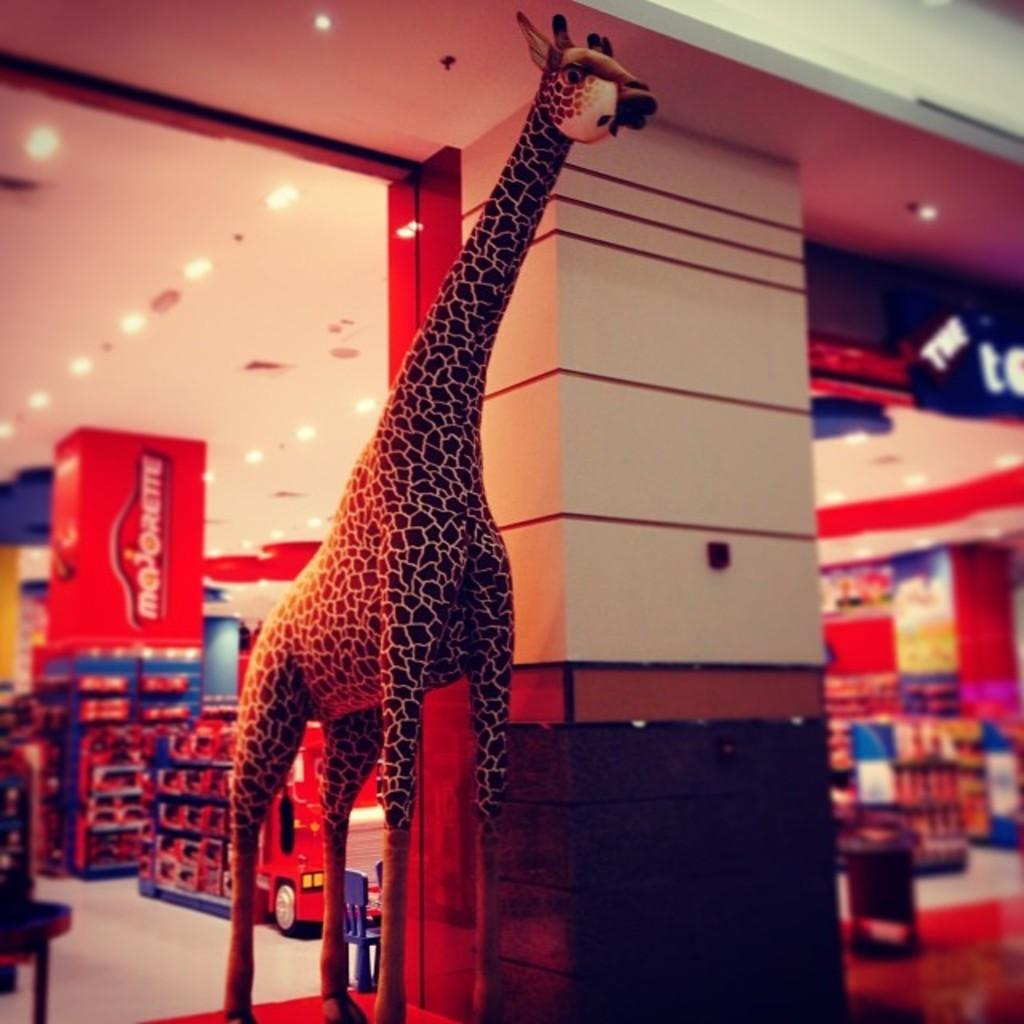What animal is depicted in the image? There is a depiction of a giraffe in the image. What type of establishment can be seen in the background of the image? There is a store in the background of the image. What can be observed in the image besides the giraffe and the store? There are objects, lights, a board, the ceiling, and the floor visible in the image. What architectural feature is present in the image? There is a pillar in the image. What type of key is used to unlock the yoke in the image? There is no key or yoke present in the image; it features a depiction of a giraffe and a store. What type of calculator is visible on the board in the image? There is no calculator visible on the board in the image; it features a board with other unspecified content. 